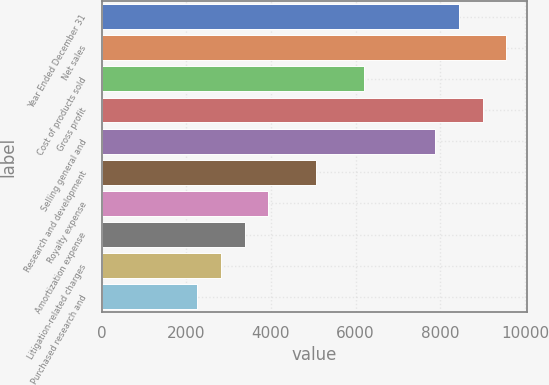<chart> <loc_0><loc_0><loc_500><loc_500><bar_chart><fcel>Year Ended December 31<fcel>Net sales<fcel>Cost of products sold<fcel>Gross profit<fcel>Selling general and<fcel>Research and development<fcel>Royalty expense<fcel>Amortization expense<fcel>Litigation-related charges<fcel>Purchased research and<nl><fcel>8435.44<fcel>9560<fcel>6186.32<fcel>8997.72<fcel>7873.16<fcel>5061.76<fcel>3937.2<fcel>3374.92<fcel>2812.64<fcel>2250.36<nl></chart> 